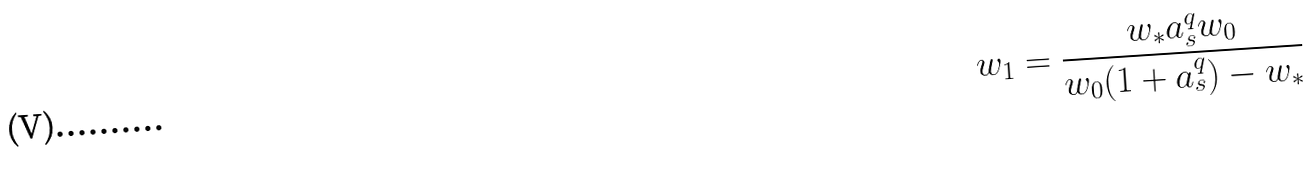<formula> <loc_0><loc_0><loc_500><loc_500>w _ { 1 } = \frac { w _ { * } a _ { s } ^ { q } w _ { 0 } } { w _ { 0 } ( 1 + a _ { s } ^ { q } ) - w _ { * } }</formula> 